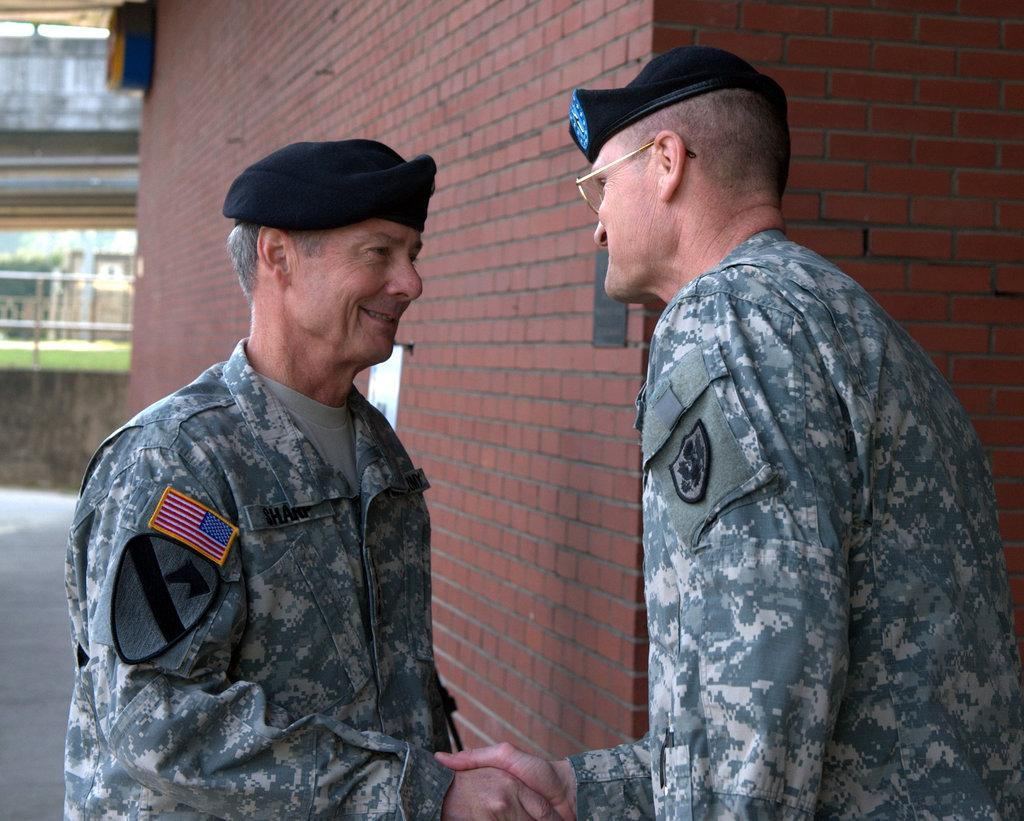How many army people are in the image? There are two army people in the image. What are the army people wearing on their heads? The army people are wearing hats. What are the army people doing in the image? The army people are shaking hands. What can be seen in the distance behind the army people? There are buildings visible in the background of the image. Can you see any crackers floating in the water near the army people in the image? There is no water or crackers present in the image; it features two army people shaking hands with buildings in the background. 